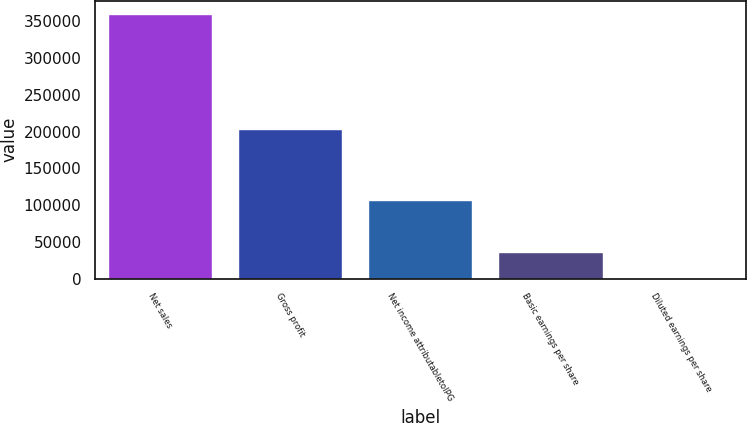Convert chart. <chart><loc_0><loc_0><loc_500><loc_500><bar_chart><fcel>Net sales<fcel>Gross profit<fcel>Net income attributabletoIPG<fcel>Basic earnings per share<fcel>Diluted earnings per share<nl><fcel>359864<fcel>203362<fcel>106334<fcel>35988.1<fcel>1.93<nl></chart> 